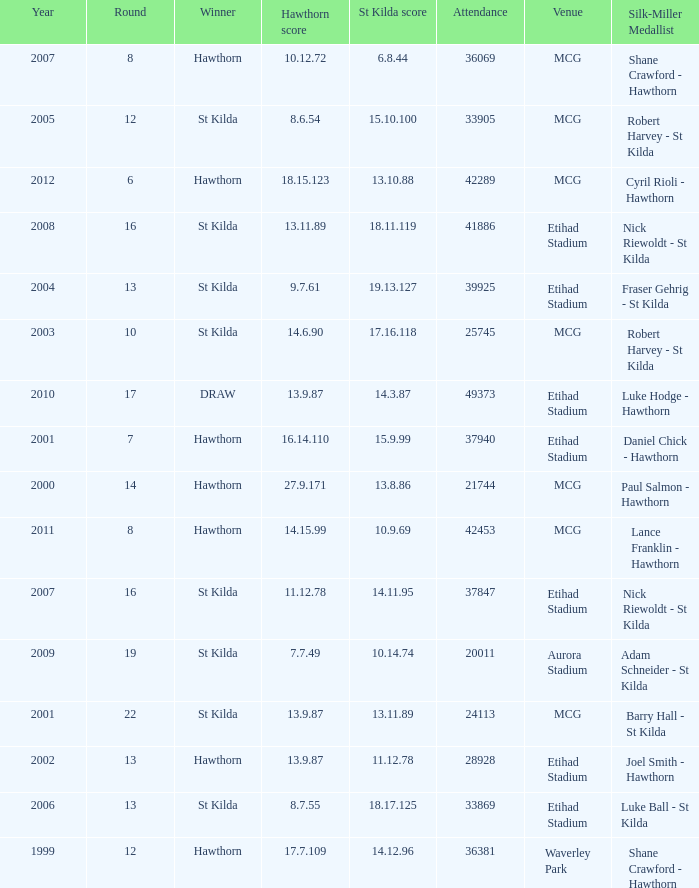What is the attendance when the st kilda score is 13.10.88? 42289.0. 